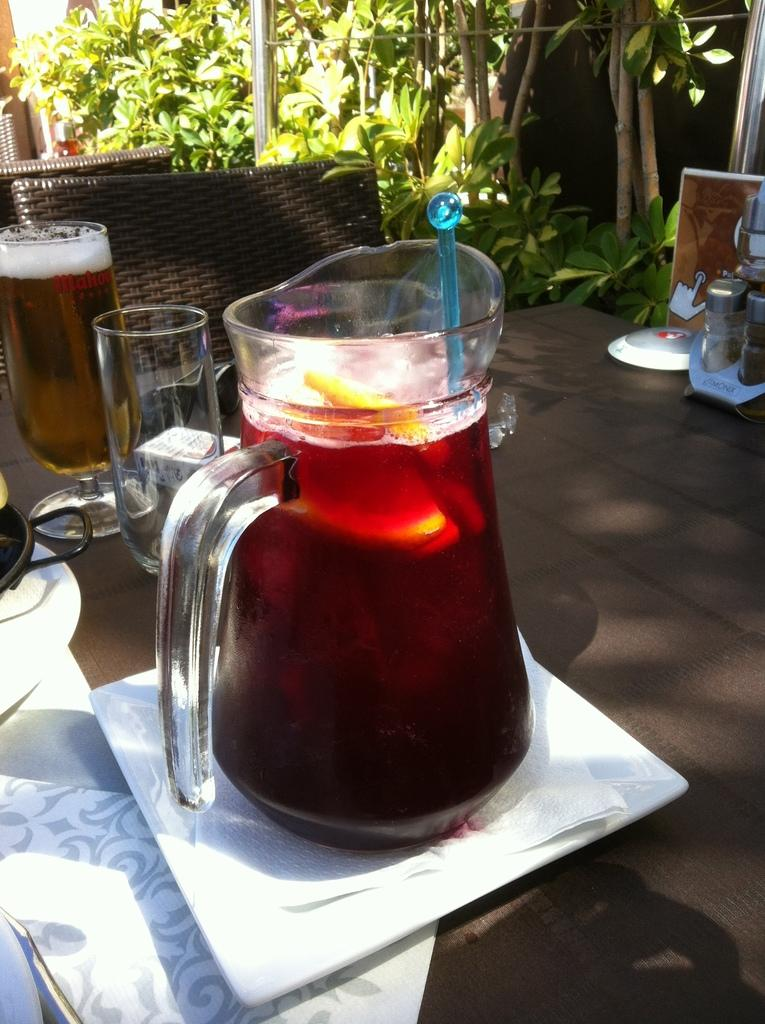What is on the table in the image? There is a jar, a glass, a plate, and tissues on the table in the image. What type of furniture is located behind the table? There are chairs behind the table. What can be seen in the background of the image? Trees are visible at the back of the image. What type of bottle is being shaken in the image? There is no bottle present in the image, and no shaking is taking place. What type of stew is being served on the plate in the image? There is no stew present in the image; only a plate is visible on the table. 